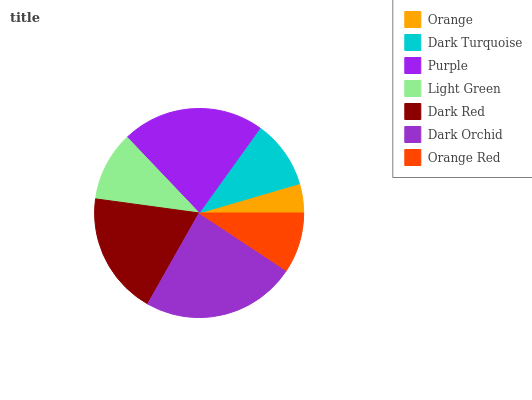Is Orange the minimum?
Answer yes or no. Yes. Is Dark Orchid the maximum?
Answer yes or no. Yes. Is Dark Turquoise the minimum?
Answer yes or no. No. Is Dark Turquoise the maximum?
Answer yes or no. No. Is Dark Turquoise greater than Orange?
Answer yes or no. Yes. Is Orange less than Dark Turquoise?
Answer yes or no. Yes. Is Orange greater than Dark Turquoise?
Answer yes or no. No. Is Dark Turquoise less than Orange?
Answer yes or no. No. Is Light Green the high median?
Answer yes or no. Yes. Is Light Green the low median?
Answer yes or no. Yes. Is Orange the high median?
Answer yes or no. No. Is Purple the low median?
Answer yes or no. No. 